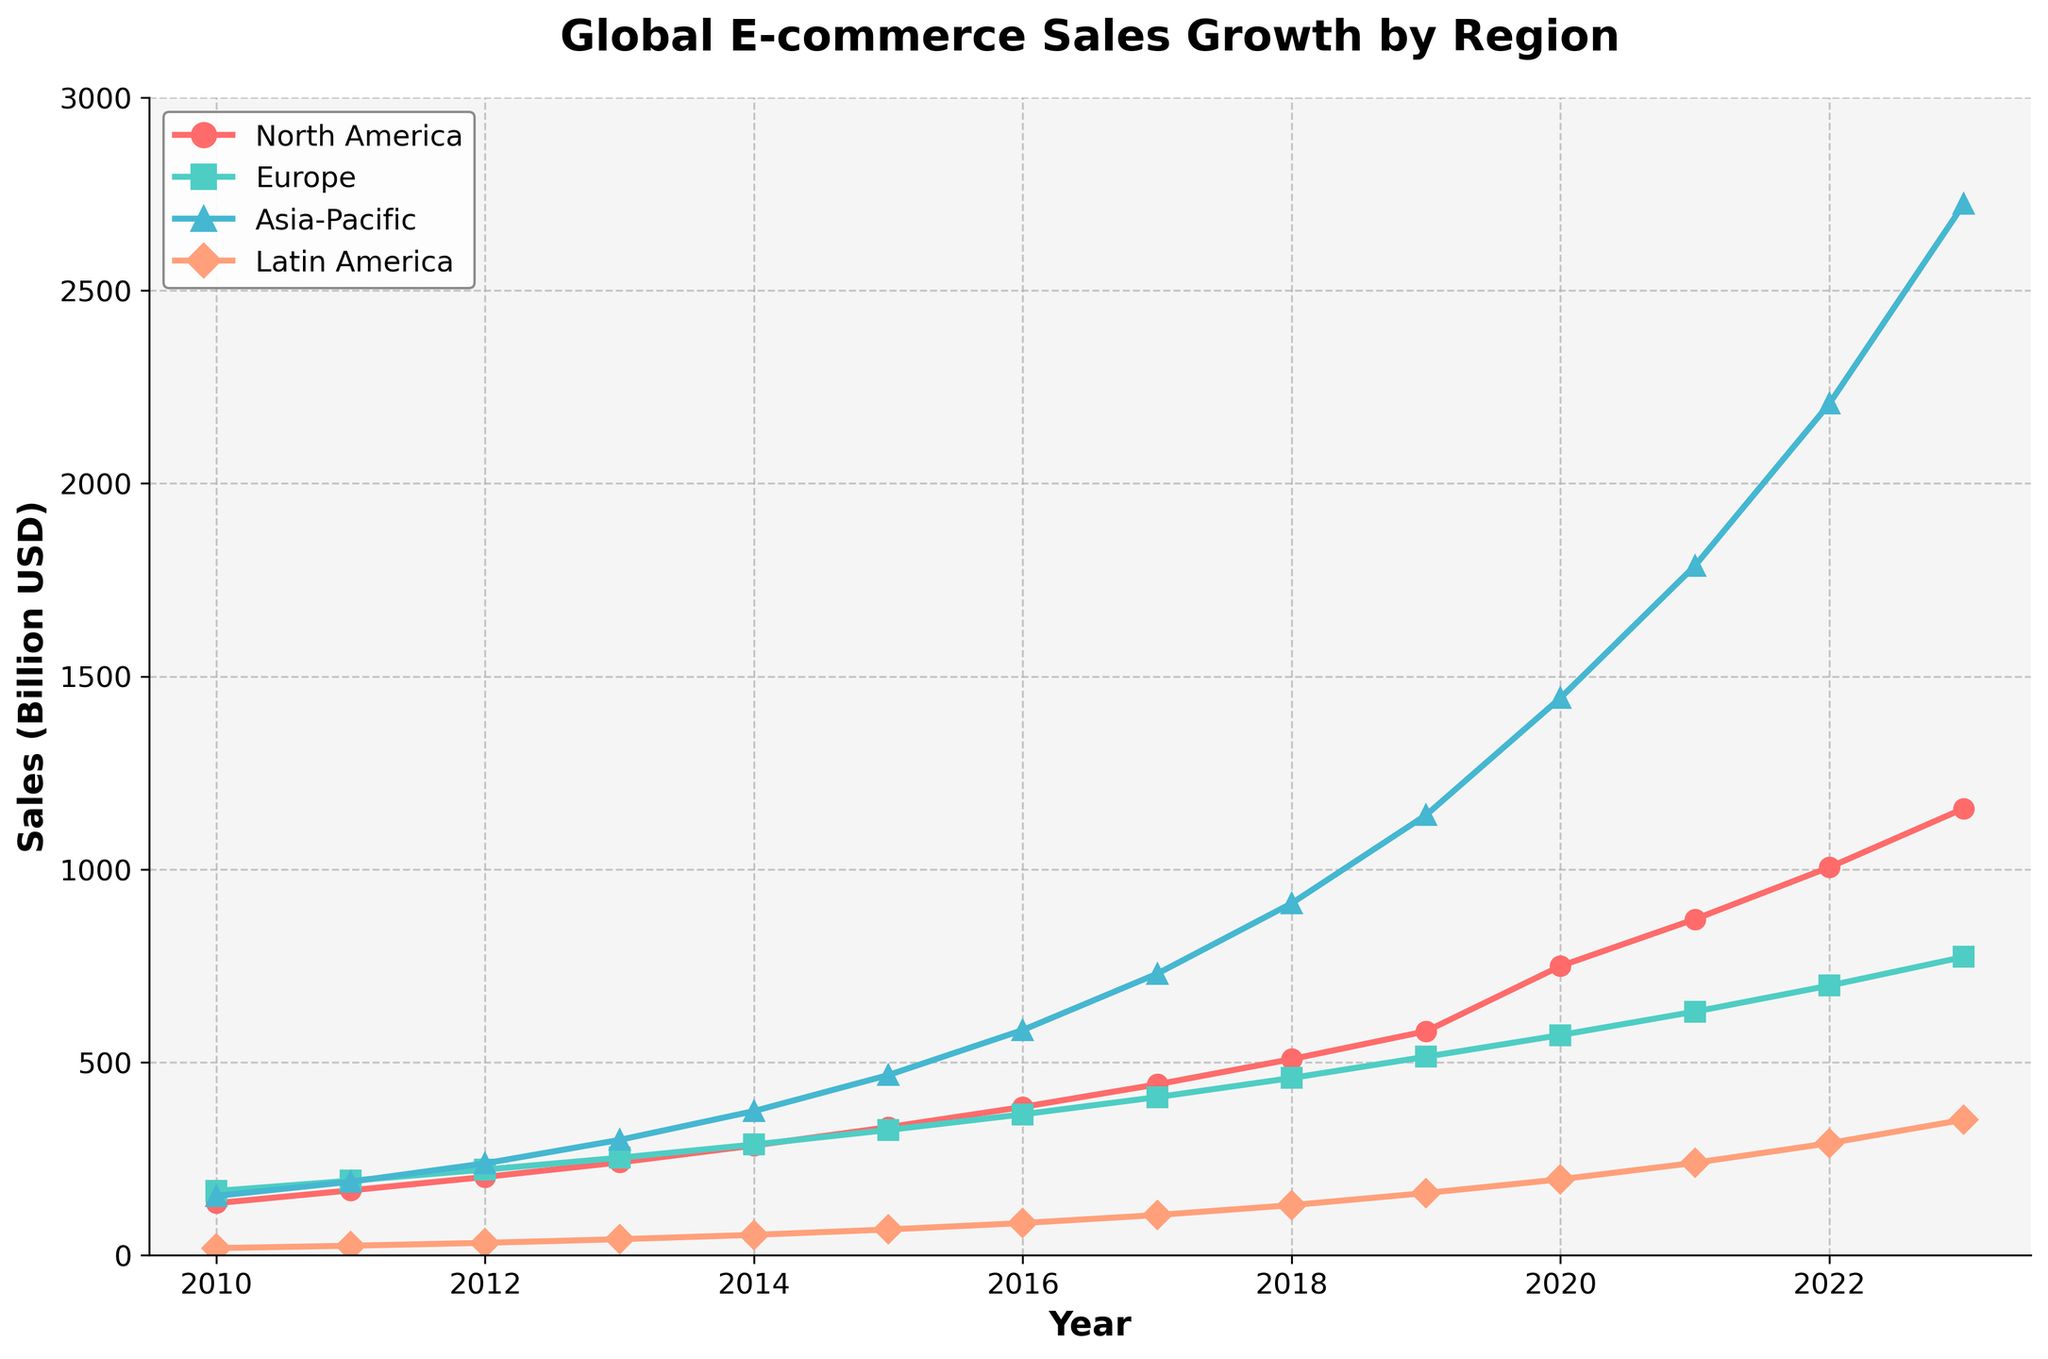Which region showed the highest sales growth from 2010 to 2023? By looking at the end value in 2023, the region with the highest sales is Asia-Pacific with 2723.9 billion USD.
Answer: Asia-Pacific What is the sum of e-commerce sales in North America and Europe in 2020? The e-commerce sales in North America in 2020 is 749.3 billion USD and in Europe, it is 570.5 billion USD. Adding these together, 749.3 + 570.5 = 1319.8 billion USD.
Answer: 1319.8 billion USD Compare the sales in Asia-Pacific and Latin America in 2014. Which region had higher sales? The sales in Asia-Pacific in 2014 were 373.5 billion USD, while in Latin America, they were 52.8 billion USD. Asia-Pacific had higher sales.
Answer: Asia-Pacific How much did sales in North America increase from 2010 to 2013? Sales in North America were 134.9 billion USD in 2010 and increased to 240.5 billion USD in 2013. So, the increase is 240.5 - 134.9 = 105.6 billion USD.
Answer: 105.6 billion USD What is the average annual sales in Europe from 2010 to 2013? The sales in Europe were 166.5, 193.2, 221.9, and 252.6 billion USD from 2010 to 2013, respectively. The average is (166.5 + 193.2 + 221.9 + 252.6)/4 = 208.55 billion USD.
Answer: 208.55 billion USD How did Latin America's sales growth from 2010 to 2023 visually compare to other regions? Latin America's growth appears to be the slowest visually, the line representing it does not rise as steeply as those of the other regions. Asia-Pacific has the steepest growth.
Answer: Slowest growth What visual patterns can you identify in the e-commerce sales trend for Europe? Europe's sales trend shows a steady and consistent increase from 2010 to 2023, with no sudden spikes or drops.
Answer: Steady and consistent increase What is the difference in sales between North America and Asia-Pacific in 2021? The sales in North America in 2021 were 870.8 billion USD and in Asia-Pacific, the sales were 1786.3 billion USD. The difference is 1786.3 - 870.8 = 915.5 billion USD.
Answer: 915.5 billion USD In which years did Europe and Latin America have similar sales figures? Europe and Latin America never had similar sales figures; Europe always had higher sales than Latin America in every year shown.
Answer: Never had similar sales 